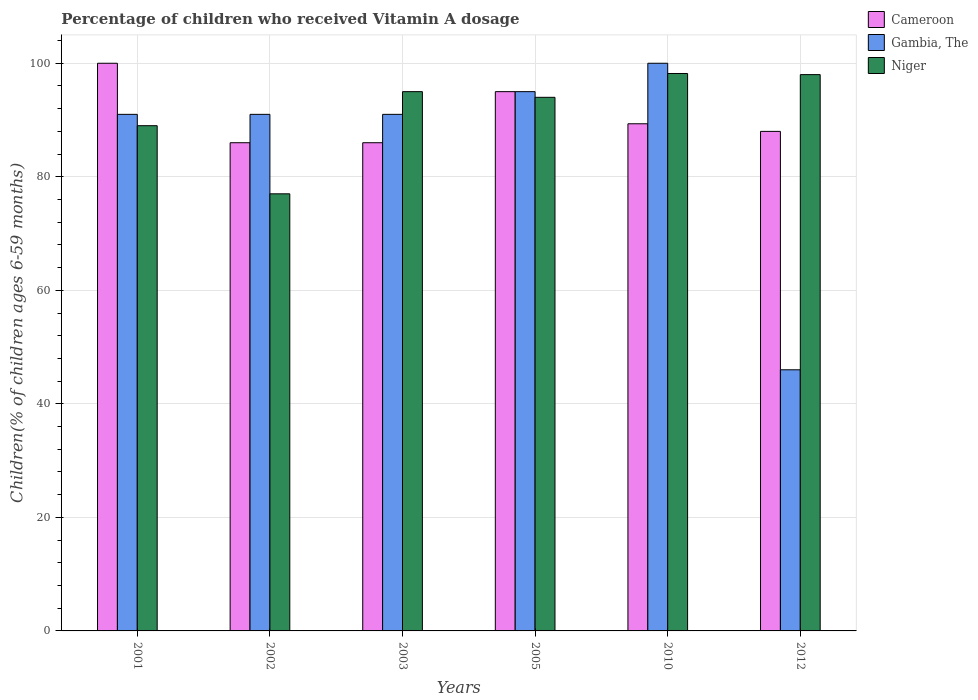How many different coloured bars are there?
Your answer should be compact. 3. How many groups of bars are there?
Make the answer very short. 6. Are the number of bars per tick equal to the number of legend labels?
Provide a short and direct response. Yes. Are the number of bars on each tick of the X-axis equal?
Offer a very short reply. Yes. How many bars are there on the 3rd tick from the right?
Provide a succinct answer. 3. What is the percentage of children who received Vitamin A dosage in Cameroon in 2001?
Ensure brevity in your answer.  100. Across all years, what is the minimum percentage of children who received Vitamin A dosage in Gambia, The?
Your response must be concise. 46. What is the total percentage of children who received Vitamin A dosage in Niger in the graph?
Offer a very short reply. 551.2. What is the difference between the percentage of children who received Vitamin A dosage in Niger in 2010 and that in 2012?
Give a very brief answer. 0.2. What is the difference between the percentage of children who received Vitamin A dosage in Cameroon in 2010 and the percentage of children who received Vitamin A dosage in Gambia, The in 2003?
Ensure brevity in your answer.  -1.66. What is the average percentage of children who received Vitamin A dosage in Gambia, The per year?
Offer a very short reply. 85.67. In how many years, is the percentage of children who received Vitamin A dosage in Gambia, The greater than 8 %?
Make the answer very short. 6. What is the ratio of the percentage of children who received Vitamin A dosage in Gambia, The in 2003 to that in 2012?
Your response must be concise. 1.98. Is the percentage of children who received Vitamin A dosage in Gambia, The in 2005 less than that in 2010?
Offer a terse response. Yes. Is the difference between the percentage of children who received Vitamin A dosage in Niger in 2003 and 2005 greater than the difference between the percentage of children who received Vitamin A dosage in Gambia, The in 2003 and 2005?
Give a very brief answer. Yes. In how many years, is the percentage of children who received Vitamin A dosage in Gambia, The greater than the average percentage of children who received Vitamin A dosage in Gambia, The taken over all years?
Ensure brevity in your answer.  5. What does the 2nd bar from the left in 2005 represents?
Ensure brevity in your answer.  Gambia, The. What does the 3rd bar from the right in 2012 represents?
Give a very brief answer. Cameroon. Are all the bars in the graph horizontal?
Your response must be concise. No. Are the values on the major ticks of Y-axis written in scientific E-notation?
Offer a terse response. No. Does the graph contain grids?
Your response must be concise. Yes. How many legend labels are there?
Provide a short and direct response. 3. How are the legend labels stacked?
Your answer should be compact. Vertical. What is the title of the graph?
Your answer should be very brief. Percentage of children who received Vitamin A dosage. Does "Kyrgyz Republic" appear as one of the legend labels in the graph?
Give a very brief answer. No. What is the label or title of the Y-axis?
Give a very brief answer. Children(% of children ages 6-59 months). What is the Children(% of children ages 6-59 months) in Cameroon in 2001?
Provide a succinct answer. 100. What is the Children(% of children ages 6-59 months) in Gambia, The in 2001?
Give a very brief answer. 91. What is the Children(% of children ages 6-59 months) of Niger in 2001?
Offer a terse response. 89. What is the Children(% of children ages 6-59 months) in Cameroon in 2002?
Provide a short and direct response. 86. What is the Children(% of children ages 6-59 months) of Gambia, The in 2002?
Ensure brevity in your answer.  91. What is the Children(% of children ages 6-59 months) of Niger in 2002?
Ensure brevity in your answer.  77. What is the Children(% of children ages 6-59 months) of Cameroon in 2003?
Your response must be concise. 86. What is the Children(% of children ages 6-59 months) of Gambia, The in 2003?
Offer a very short reply. 91. What is the Children(% of children ages 6-59 months) of Gambia, The in 2005?
Provide a short and direct response. 95. What is the Children(% of children ages 6-59 months) of Niger in 2005?
Your answer should be very brief. 94. What is the Children(% of children ages 6-59 months) in Cameroon in 2010?
Offer a very short reply. 89.34. What is the Children(% of children ages 6-59 months) of Niger in 2010?
Ensure brevity in your answer.  98.2. What is the Children(% of children ages 6-59 months) of Cameroon in 2012?
Provide a short and direct response. 88. Across all years, what is the maximum Children(% of children ages 6-59 months) in Cameroon?
Give a very brief answer. 100. Across all years, what is the maximum Children(% of children ages 6-59 months) of Niger?
Keep it short and to the point. 98.2. Across all years, what is the minimum Children(% of children ages 6-59 months) of Cameroon?
Ensure brevity in your answer.  86. Across all years, what is the minimum Children(% of children ages 6-59 months) of Gambia, The?
Make the answer very short. 46. Across all years, what is the minimum Children(% of children ages 6-59 months) in Niger?
Give a very brief answer. 77. What is the total Children(% of children ages 6-59 months) in Cameroon in the graph?
Give a very brief answer. 544.34. What is the total Children(% of children ages 6-59 months) of Gambia, The in the graph?
Offer a terse response. 514. What is the total Children(% of children ages 6-59 months) of Niger in the graph?
Your response must be concise. 551.2. What is the difference between the Children(% of children ages 6-59 months) in Cameroon in 2001 and that in 2002?
Your answer should be compact. 14. What is the difference between the Children(% of children ages 6-59 months) of Gambia, The in 2001 and that in 2002?
Give a very brief answer. 0. What is the difference between the Children(% of children ages 6-59 months) in Niger in 2001 and that in 2002?
Provide a succinct answer. 12. What is the difference between the Children(% of children ages 6-59 months) in Niger in 2001 and that in 2003?
Offer a terse response. -6. What is the difference between the Children(% of children ages 6-59 months) of Cameroon in 2001 and that in 2005?
Keep it short and to the point. 5. What is the difference between the Children(% of children ages 6-59 months) in Niger in 2001 and that in 2005?
Keep it short and to the point. -5. What is the difference between the Children(% of children ages 6-59 months) of Cameroon in 2001 and that in 2010?
Offer a very short reply. 10.66. What is the difference between the Children(% of children ages 6-59 months) of Gambia, The in 2001 and that in 2010?
Keep it short and to the point. -9. What is the difference between the Children(% of children ages 6-59 months) in Niger in 2001 and that in 2010?
Offer a very short reply. -9.2. What is the difference between the Children(% of children ages 6-59 months) of Gambia, The in 2001 and that in 2012?
Ensure brevity in your answer.  45. What is the difference between the Children(% of children ages 6-59 months) of Cameroon in 2002 and that in 2003?
Offer a terse response. 0. What is the difference between the Children(% of children ages 6-59 months) of Gambia, The in 2002 and that in 2003?
Your answer should be compact. 0. What is the difference between the Children(% of children ages 6-59 months) in Cameroon in 2002 and that in 2005?
Your answer should be compact. -9. What is the difference between the Children(% of children ages 6-59 months) in Cameroon in 2002 and that in 2010?
Ensure brevity in your answer.  -3.34. What is the difference between the Children(% of children ages 6-59 months) of Niger in 2002 and that in 2010?
Offer a terse response. -21.2. What is the difference between the Children(% of children ages 6-59 months) in Cameroon in 2002 and that in 2012?
Give a very brief answer. -2. What is the difference between the Children(% of children ages 6-59 months) of Cameroon in 2003 and that in 2010?
Your response must be concise. -3.34. What is the difference between the Children(% of children ages 6-59 months) in Gambia, The in 2003 and that in 2010?
Your response must be concise. -9. What is the difference between the Children(% of children ages 6-59 months) of Niger in 2003 and that in 2010?
Provide a succinct answer. -3.2. What is the difference between the Children(% of children ages 6-59 months) in Cameroon in 2003 and that in 2012?
Provide a short and direct response. -2. What is the difference between the Children(% of children ages 6-59 months) of Gambia, The in 2003 and that in 2012?
Provide a short and direct response. 45. What is the difference between the Children(% of children ages 6-59 months) of Niger in 2003 and that in 2012?
Give a very brief answer. -3. What is the difference between the Children(% of children ages 6-59 months) of Cameroon in 2005 and that in 2010?
Keep it short and to the point. 5.66. What is the difference between the Children(% of children ages 6-59 months) of Gambia, The in 2005 and that in 2010?
Provide a succinct answer. -5. What is the difference between the Children(% of children ages 6-59 months) of Niger in 2005 and that in 2010?
Provide a succinct answer. -4.2. What is the difference between the Children(% of children ages 6-59 months) of Gambia, The in 2005 and that in 2012?
Make the answer very short. 49. What is the difference between the Children(% of children ages 6-59 months) in Cameroon in 2010 and that in 2012?
Make the answer very short. 1.34. What is the difference between the Children(% of children ages 6-59 months) in Niger in 2010 and that in 2012?
Offer a terse response. 0.2. What is the difference between the Children(% of children ages 6-59 months) in Cameroon in 2001 and the Children(% of children ages 6-59 months) in Gambia, The in 2002?
Make the answer very short. 9. What is the difference between the Children(% of children ages 6-59 months) in Cameroon in 2001 and the Children(% of children ages 6-59 months) in Niger in 2002?
Your response must be concise. 23. What is the difference between the Children(% of children ages 6-59 months) of Gambia, The in 2001 and the Children(% of children ages 6-59 months) of Niger in 2002?
Offer a terse response. 14. What is the difference between the Children(% of children ages 6-59 months) of Cameroon in 2001 and the Children(% of children ages 6-59 months) of Gambia, The in 2003?
Keep it short and to the point. 9. What is the difference between the Children(% of children ages 6-59 months) of Cameroon in 2001 and the Children(% of children ages 6-59 months) of Niger in 2003?
Your answer should be very brief. 5. What is the difference between the Children(% of children ages 6-59 months) of Gambia, The in 2001 and the Children(% of children ages 6-59 months) of Niger in 2003?
Offer a terse response. -4. What is the difference between the Children(% of children ages 6-59 months) of Cameroon in 2001 and the Children(% of children ages 6-59 months) of Niger in 2005?
Ensure brevity in your answer.  6. What is the difference between the Children(% of children ages 6-59 months) of Cameroon in 2001 and the Children(% of children ages 6-59 months) of Niger in 2010?
Offer a terse response. 1.8. What is the difference between the Children(% of children ages 6-59 months) of Gambia, The in 2001 and the Children(% of children ages 6-59 months) of Niger in 2010?
Make the answer very short. -7.2. What is the difference between the Children(% of children ages 6-59 months) of Gambia, The in 2001 and the Children(% of children ages 6-59 months) of Niger in 2012?
Offer a very short reply. -7. What is the difference between the Children(% of children ages 6-59 months) in Cameroon in 2002 and the Children(% of children ages 6-59 months) in Niger in 2003?
Make the answer very short. -9. What is the difference between the Children(% of children ages 6-59 months) of Gambia, The in 2002 and the Children(% of children ages 6-59 months) of Niger in 2003?
Make the answer very short. -4. What is the difference between the Children(% of children ages 6-59 months) of Cameroon in 2002 and the Children(% of children ages 6-59 months) of Gambia, The in 2005?
Your response must be concise. -9. What is the difference between the Children(% of children ages 6-59 months) of Cameroon in 2002 and the Children(% of children ages 6-59 months) of Niger in 2005?
Provide a succinct answer. -8. What is the difference between the Children(% of children ages 6-59 months) in Gambia, The in 2002 and the Children(% of children ages 6-59 months) in Niger in 2005?
Your response must be concise. -3. What is the difference between the Children(% of children ages 6-59 months) in Cameroon in 2002 and the Children(% of children ages 6-59 months) in Niger in 2010?
Your response must be concise. -12.2. What is the difference between the Children(% of children ages 6-59 months) in Gambia, The in 2002 and the Children(% of children ages 6-59 months) in Niger in 2010?
Keep it short and to the point. -7.2. What is the difference between the Children(% of children ages 6-59 months) in Cameroon in 2002 and the Children(% of children ages 6-59 months) in Gambia, The in 2012?
Make the answer very short. 40. What is the difference between the Children(% of children ages 6-59 months) of Cameroon in 2002 and the Children(% of children ages 6-59 months) of Niger in 2012?
Make the answer very short. -12. What is the difference between the Children(% of children ages 6-59 months) in Gambia, The in 2002 and the Children(% of children ages 6-59 months) in Niger in 2012?
Offer a very short reply. -7. What is the difference between the Children(% of children ages 6-59 months) of Cameroon in 2003 and the Children(% of children ages 6-59 months) of Gambia, The in 2005?
Make the answer very short. -9. What is the difference between the Children(% of children ages 6-59 months) of Cameroon in 2003 and the Children(% of children ages 6-59 months) of Niger in 2010?
Your answer should be very brief. -12.2. What is the difference between the Children(% of children ages 6-59 months) in Gambia, The in 2003 and the Children(% of children ages 6-59 months) in Niger in 2010?
Offer a terse response. -7.2. What is the difference between the Children(% of children ages 6-59 months) in Cameroon in 2003 and the Children(% of children ages 6-59 months) in Niger in 2012?
Keep it short and to the point. -12. What is the difference between the Children(% of children ages 6-59 months) in Gambia, The in 2003 and the Children(% of children ages 6-59 months) in Niger in 2012?
Give a very brief answer. -7. What is the difference between the Children(% of children ages 6-59 months) in Cameroon in 2005 and the Children(% of children ages 6-59 months) in Gambia, The in 2010?
Make the answer very short. -5. What is the difference between the Children(% of children ages 6-59 months) of Cameroon in 2005 and the Children(% of children ages 6-59 months) of Niger in 2010?
Your response must be concise. -3.2. What is the difference between the Children(% of children ages 6-59 months) in Gambia, The in 2005 and the Children(% of children ages 6-59 months) in Niger in 2010?
Ensure brevity in your answer.  -3.2. What is the difference between the Children(% of children ages 6-59 months) of Gambia, The in 2005 and the Children(% of children ages 6-59 months) of Niger in 2012?
Provide a short and direct response. -3. What is the difference between the Children(% of children ages 6-59 months) in Cameroon in 2010 and the Children(% of children ages 6-59 months) in Gambia, The in 2012?
Keep it short and to the point. 43.34. What is the difference between the Children(% of children ages 6-59 months) in Cameroon in 2010 and the Children(% of children ages 6-59 months) in Niger in 2012?
Offer a very short reply. -8.66. What is the difference between the Children(% of children ages 6-59 months) in Gambia, The in 2010 and the Children(% of children ages 6-59 months) in Niger in 2012?
Ensure brevity in your answer.  2. What is the average Children(% of children ages 6-59 months) of Cameroon per year?
Provide a short and direct response. 90.72. What is the average Children(% of children ages 6-59 months) in Gambia, The per year?
Give a very brief answer. 85.67. What is the average Children(% of children ages 6-59 months) of Niger per year?
Your answer should be compact. 91.87. In the year 2002, what is the difference between the Children(% of children ages 6-59 months) in Cameroon and Children(% of children ages 6-59 months) in Gambia, The?
Give a very brief answer. -5. In the year 2002, what is the difference between the Children(% of children ages 6-59 months) in Gambia, The and Children(% of children ages 6-59 months) in Niger?
Provide a succinct answer. 14. In the year 2003, what is the difference between the Children(% of children ages 6-59 months) in Cameroon and Children(% of children ages 6-59 months) in Niger?
Offer a very short reply. -9. In the year 2003, what is the difference between the Children(% of children ages 6-59 months) of Gambia, The and Children(% of children ages 6-59 months) of Niger?
Your answer should be compact. -4. In the year 2005, what is the difference between the Children(% of children ages 6-59 months) in Cameroon and Children(% of children ages 6-59 months) in Niger?
Provide a succinct answer. 1. In the year 2010, what is the difference between the Children(% of children ages 6-59 months) of Cameroon and Children(% of children ages 6-59 months) of Gambia, The?
Make the answer very short. -10.66. In the year 2010, what is the difference between the Children(% of children ages 6-59 months) of Cameroon and Children(% of children ages 6-59 months) of Niger?
Offer a terse response. -8.86. In the year 2010, what is the difference between the Children(% of children ages 6-59 months) of Gambia, The and Children(% of children ages 6-59 months) of Niger?
Your response must be concise. 1.8. In the year 2012, what is the difference between the Children(% of children ages 6-59 months) of Cameroon and Children(% of children ages 6-59 months) of Niger?
Make the answer very short. -10. In the year 2012, what is the difference between the Children(% of children ages 6-59 months) in Gambia, The and Children(% of children ages 6-59 months) in Niger?
Your answer should be very brief. -52. What is the ratio of the Children(% of children ages 6-59 months) in Cameroon in 2001 to that in 2002?
Offer a terse response. 1.16. What is the ratio of the Children(% of children ages 6-59 months) in Gambia, The in 2001 to that in 2002?
Offer a very short reply. 1. What is the ratio of the Children(% of children ages 6-59 months) of Niger in 2001 to that in 2002?
Your answer should be compact. 1.16. What is the ratio of the Children(% of children ages 6-59 months) of Cameroon in 2001 to that in 2003?
Keep it short and to the point. 1.16. What is the ratio of the Children(% of children ages 6-59 months) of Gambia, The in 2001 to that in 2003?
Give a very brief answer. 1. What is the ratio of the Children(% of children ages 6-59 months) of Niger in 2001 to that in 2003?
Your response must be concise. 0.94. What is the ratio of the Children(% of children ages 6-59 months) in Cameroon in 2001 to that in 2005?
Your answer should be compact. 1.05. What is the ratio of the Children(% of children ages 6-59 months) of Gambia, The in 2001 to that in 2005?
Offer a very short reply. 0.96. What is the ratio of the Children(% of children ages 6-59 months) of Niger in 2001 to that in 2005?
Your answer should be very brief. 0.95. What is the ratio of the Children(% of children ages 6-59 months) in Cameroon in 2001 to that in 2010?
Provide a short and direct response. 1.12. What is the ratio of the Children(% of children ages 6-59 months) of Gambia, The in 2001 to that in 2010?
Make the answer very short. 0.91. What is the ratio of the Children(% of children ages 6-59 months) in Niger in 2001 to that in 2010?
Make the answer very short. 0.91. What is the ratio of the Children(% of children ages 6-59 months) of Cameroon in 2001 to that in 2012?
Offer a very short reply. 1.14. What is the ratio of the Children(% of children ages 6-59 months) in Gambia, The in 2001 to that in 2012?
Provide a short and direct response. 1.98. What is the ratio of the Children(% of children ages 6-59 months) in Niger in 2001 to that in 2012?
Ensure brevity in your answer.  0.91. What is the ratio of the Children(% of children ages 6-59 months) in Cameroon in 2002 to that in 2003?
Give a very brief answer. 1. What is the ratio of the Children(% of children ages 6-59 months) in Gambia, The in 2002 to that in 2003?
Offer a terse response. 1. What is the ratio of the Children(% of children ages 6-59 months) in Niger in 2002 to that in 2003?
Keep it short and to the point. 0.81. What is the ratio of the Children(% of children ages 6-59 months) in Cameroon in 2002 to that in 2005?
Your answer should be compact. 0.91. What is the ratio of the Children(% of children ages 6-59 months) of Gambia, The in 2002 to that in 2005?
Offer a very short reply. 0.96. What is the ratio of the Children(% of children ages 6-59 months) in Niger in 2002 to that in 2005?
Your answer should be very brief. 0.82. What is the ratio of the Children(% of children ages 6-59 months) of Cameroon in 2002 to that in 2010?
Your answer should be very brief. 0.96. What is the ratio of the Children(% of children ages 6-59 months) of Gambia, The in 2002 to that in 2010?
Offer a terse response. 0.91. What is the ratio of the Children(% of children ages 6-59 months) in Niger in 2002 to that in 2010?
Provide a short and direct response. 0.78. What is the ratio of the Children(% of children ages 6-59 months) of Cameroon in 2002 to that in 2012?
Your answer should be compact. 0.98. What is the ratio of the Children(% of children ages 6-59 months) of Gambia, The in 2002 to that in 2012?
Your answer should be very brief. 1.98. What is the ratio of the Children(% of children ages 6-59 months) in Niger in 2002 to that in 2012?
Ensure brevity in your answer.  0.79. What is the ratio of the Children(% of children ages 6-59 months) of Cameroon in 2003 to that in 2005?
Provide a succinct answer. 0.91. What is the ratio of the Children(% of children ages 6-59 months) of Gambia, The in 2003 to that in 2005?
Give a very brief answer. 0.96. What is the ratio of the Children(% of children ages 6-59 months) of Niger in 2003 to that in 2005?
Provide a short and direct response. 1.01. What is the ratio of the Children(% of children ages 6-59 months) in Cameroon in 2003 to that in 2010?
Give a very brief answer. 0.96. What is the ratio of the Children(% of children ages 6-59 months) in Gambia, The in 2003 to that in 2010?
Make the answer very short. 0.91. What is the ratio of the Children(% of children ages 6-59 months) of Niger in 2003 to that in 2010?
Provide a succinct answer. 0.97. What is the ratio of the Children(% of children ages 6-59 months) of Cameroon in 2003 to that in 2012?
Make the answer very short. 0.98. What is the ratio of the Children(% of children ages 6-59 months) in Gambia, The in 2003 to that in 2012?
Offer a very short reply. 1.98. What is the ratio of the Children(% of children ages 6-59 months) in Niger in 2003 to that in 2012?
Give a very brief answer. 0.97. What is the ratio of the Children(% of children ages 6-59 months) in Cameroon in 2005 to that in 2010?
Provide a short and direct response. 1.06. What is the ratio of the Children(% of children ages 6-59 months) in Niger in 2005 to that in 2010?
Keep it short and to the point. 0.96. What is the ratio of the Children(% of children ages 6-59 months) of Cameroon in 2005 to that in 2012?
Make the answer very short. 1.08. What is the ratio of the Children(% of children ages 6-59 months) of Gambia, The in 2005 to that in 2012?
Provide a short and direct response. 2.07. What is the ratio of the Children(% of children ages 6-59 months) in Niger in 2005 to that in 2012?
Provide a succinct answer. 0.96. What is the ratio of the Children(% of children ages 6-59 months) of Cameroon in 2010 to that in 2012?
Offer a terse response. 1.02. What is the ratio of the Children(% of children ages 6-59 months) in Gambia, The in 2010 to that in 2012?
Your answer should be compact. 2.17. What is the difference between the highest and the second highest Children(% of children ages 6-59 months) in Niger?
Ensure brevity in your answer.  0.2. What is the difference between the highest and the lowest Children(% of children ages 6-59 months) of Cameroon?
Provide a succinct answer. 14. What is the difference between the highest and the lowest Children(% of children ages 6-59 months) in Niger?
Your answer should be compact. 21.2. 